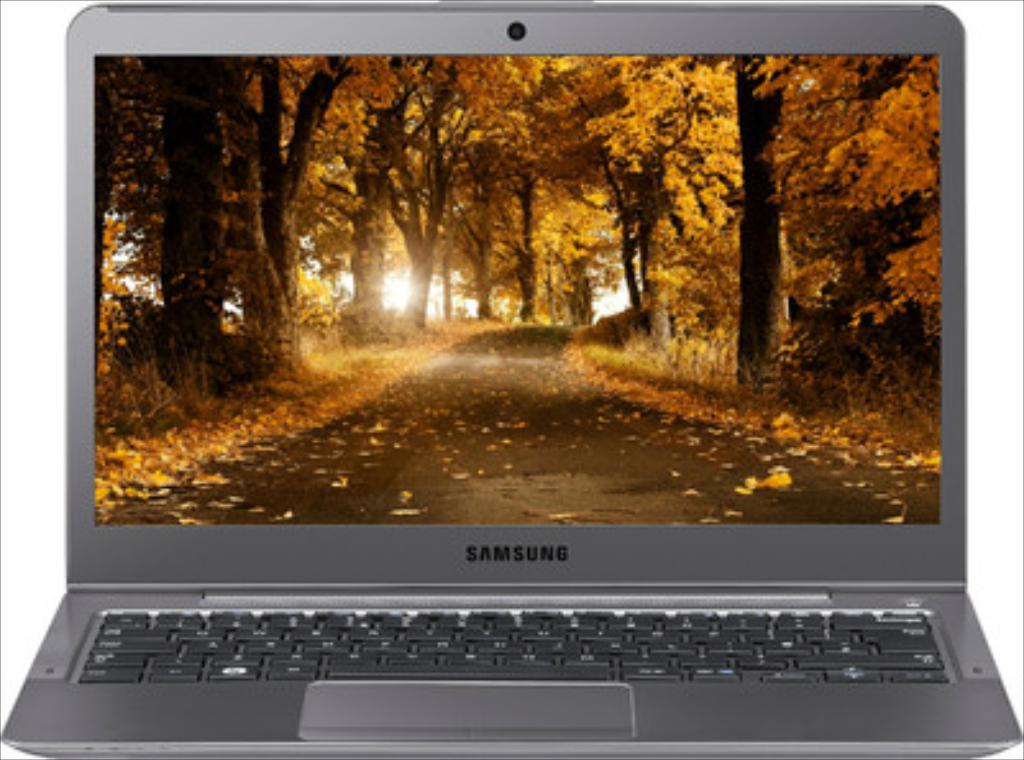What electronic device is present in the image? There is a laptop in the image. What is the purpose of the screen hire in the image? The screen hire is used to display something, in this case, trees. What can be seen on the screen? The screen displays trees. What type of outdoor setting can be seen in the image? There is a road visible in the image, which suggests an outdoor setting. What type of ornament is hanging from the trees on the screen? There is no ornament hanging from the trees on the screen; the screen displays trees without any additional decorations. 